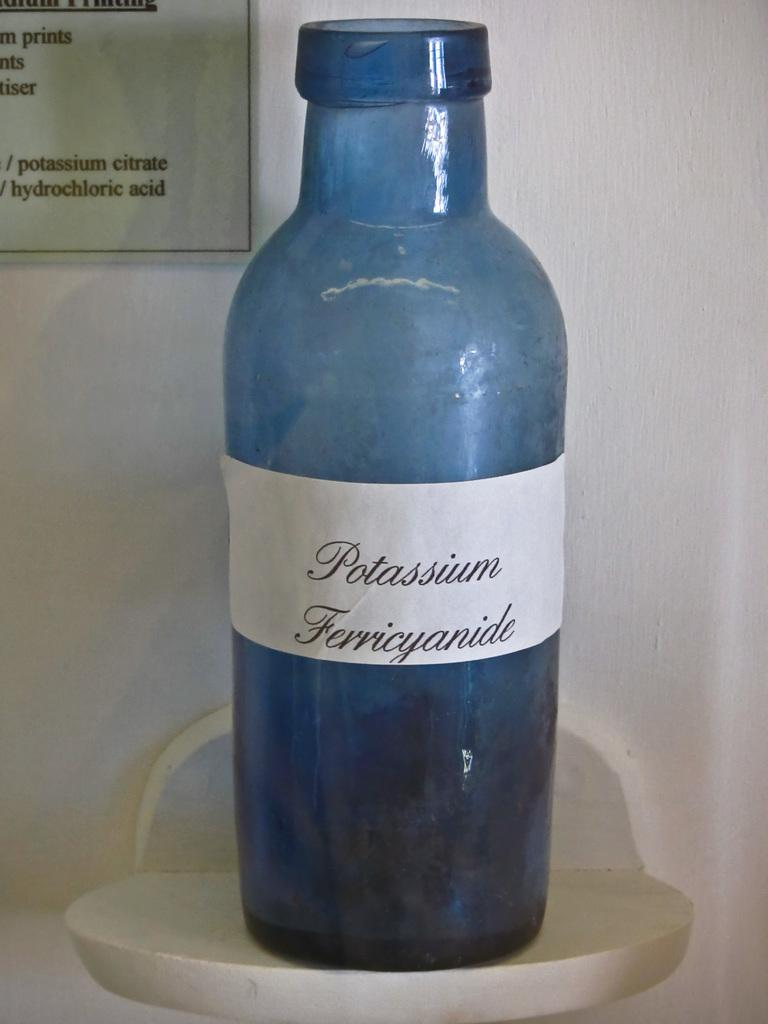<image>
Describe the image concisely. In a display stands a blue bottle of potassium ferricyanide. 